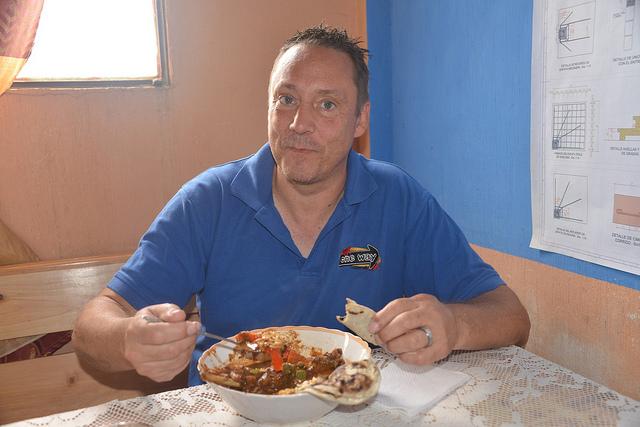What is in his left hand?
Give a very brief answer. Tortilla. Where is the fork?
Answer briefly. Hand. Is the man wearing a ring?
Short answer required. Yes. What size bowl is he using?
Keep it brief. Large. 